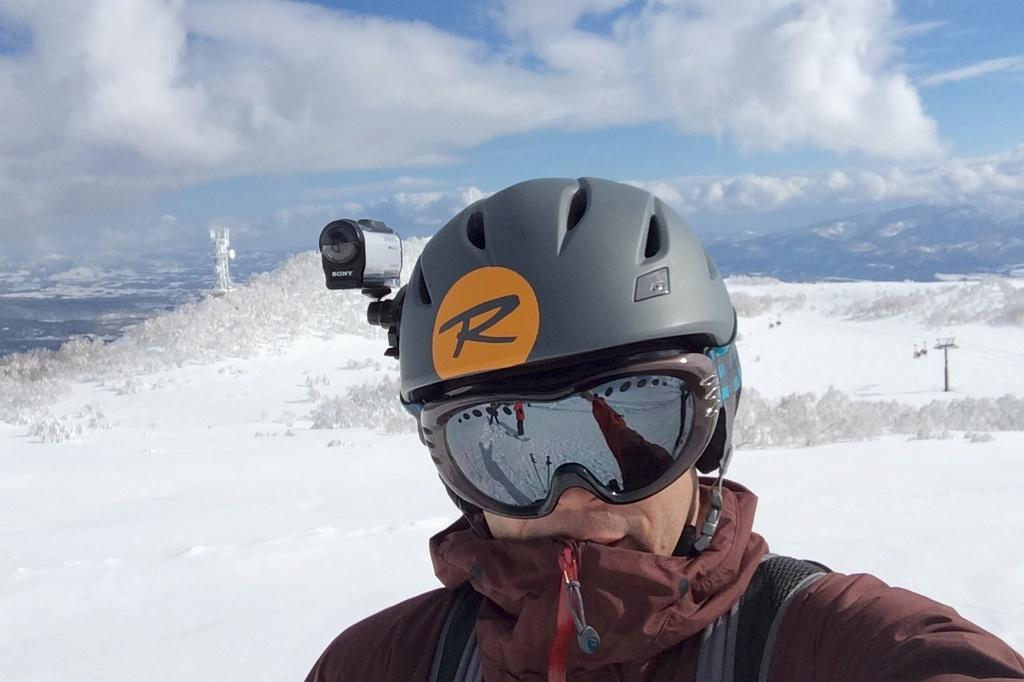What is the main subject of the image? There is a person in the image. What is the person wearing on their face? The person is wearing a spectacle. What is the person wearing on their head? The person is wearing a helmet. What is attached to the helmet? There is a camera on the helmet. What is visible at the top of the image? The sky is visible at the top of the image. What can be seen in the middle of the image? There is a snow hill in the middle of the image. How many cherries can be seen on the snow hill in the image? There are no cherries present in the image; it features a person wearing a spectacle, helmet, and camera, as well as a snow hill. What type of pest is visible on the person's helmet in the image? There are no pests visible on the person's helmet in the image. 